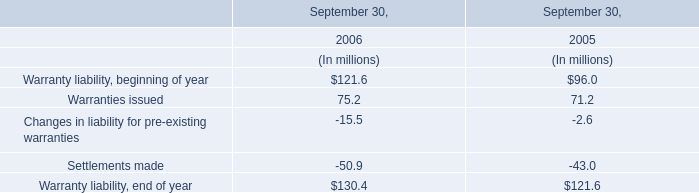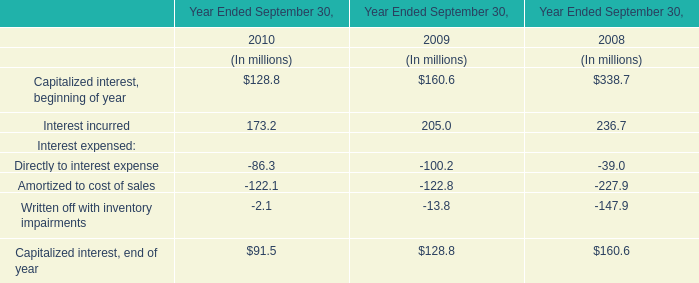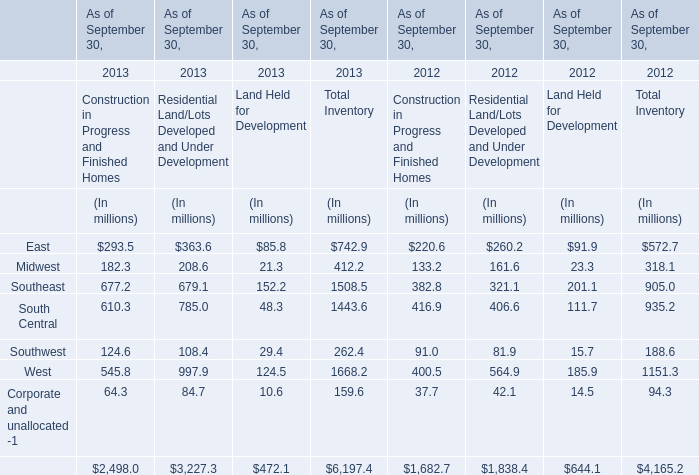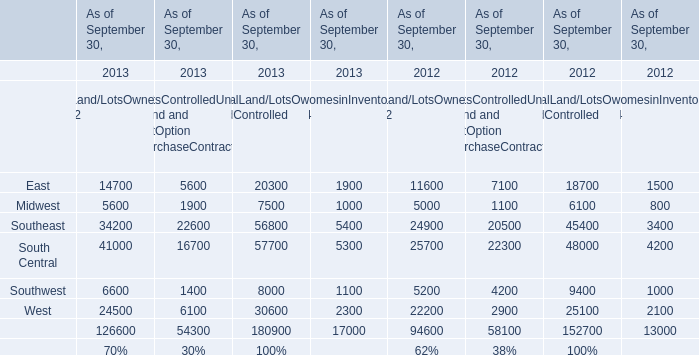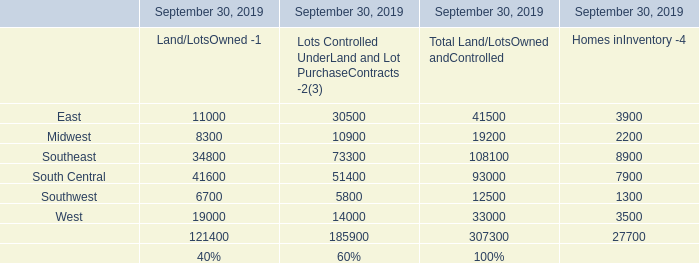What is the sum of Warranties issued in 2006 and Interest incurred in 2008? (in million) 
Computations: (75.2 + 236.7)
Answer: 311.9. 